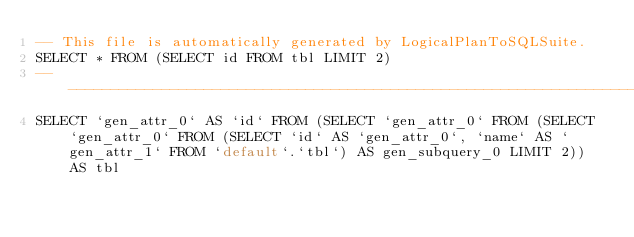Convert code to text. <code><loc_0><loc_0><loc_500><loc_500><_SQL_>-- This file is automatically generated by LogicalPlanToSQLSuite.
SELECT * FROM (SELECT id FROM tbl LIMIT 2)
--------------------------------------------------------------------------------
SELECT `gen_attr_0` AS `id` FROM (SELECT `gen_attr_0` FROM (SELECT `gen_attr_0` FROM (SELECT `id` AS `gen_attr_0`, `name` AS `gen_attr_1` FROM `default`.`tbl`) AS gen_subquery_0 LIMIT 2)) AS tbl
</code> 